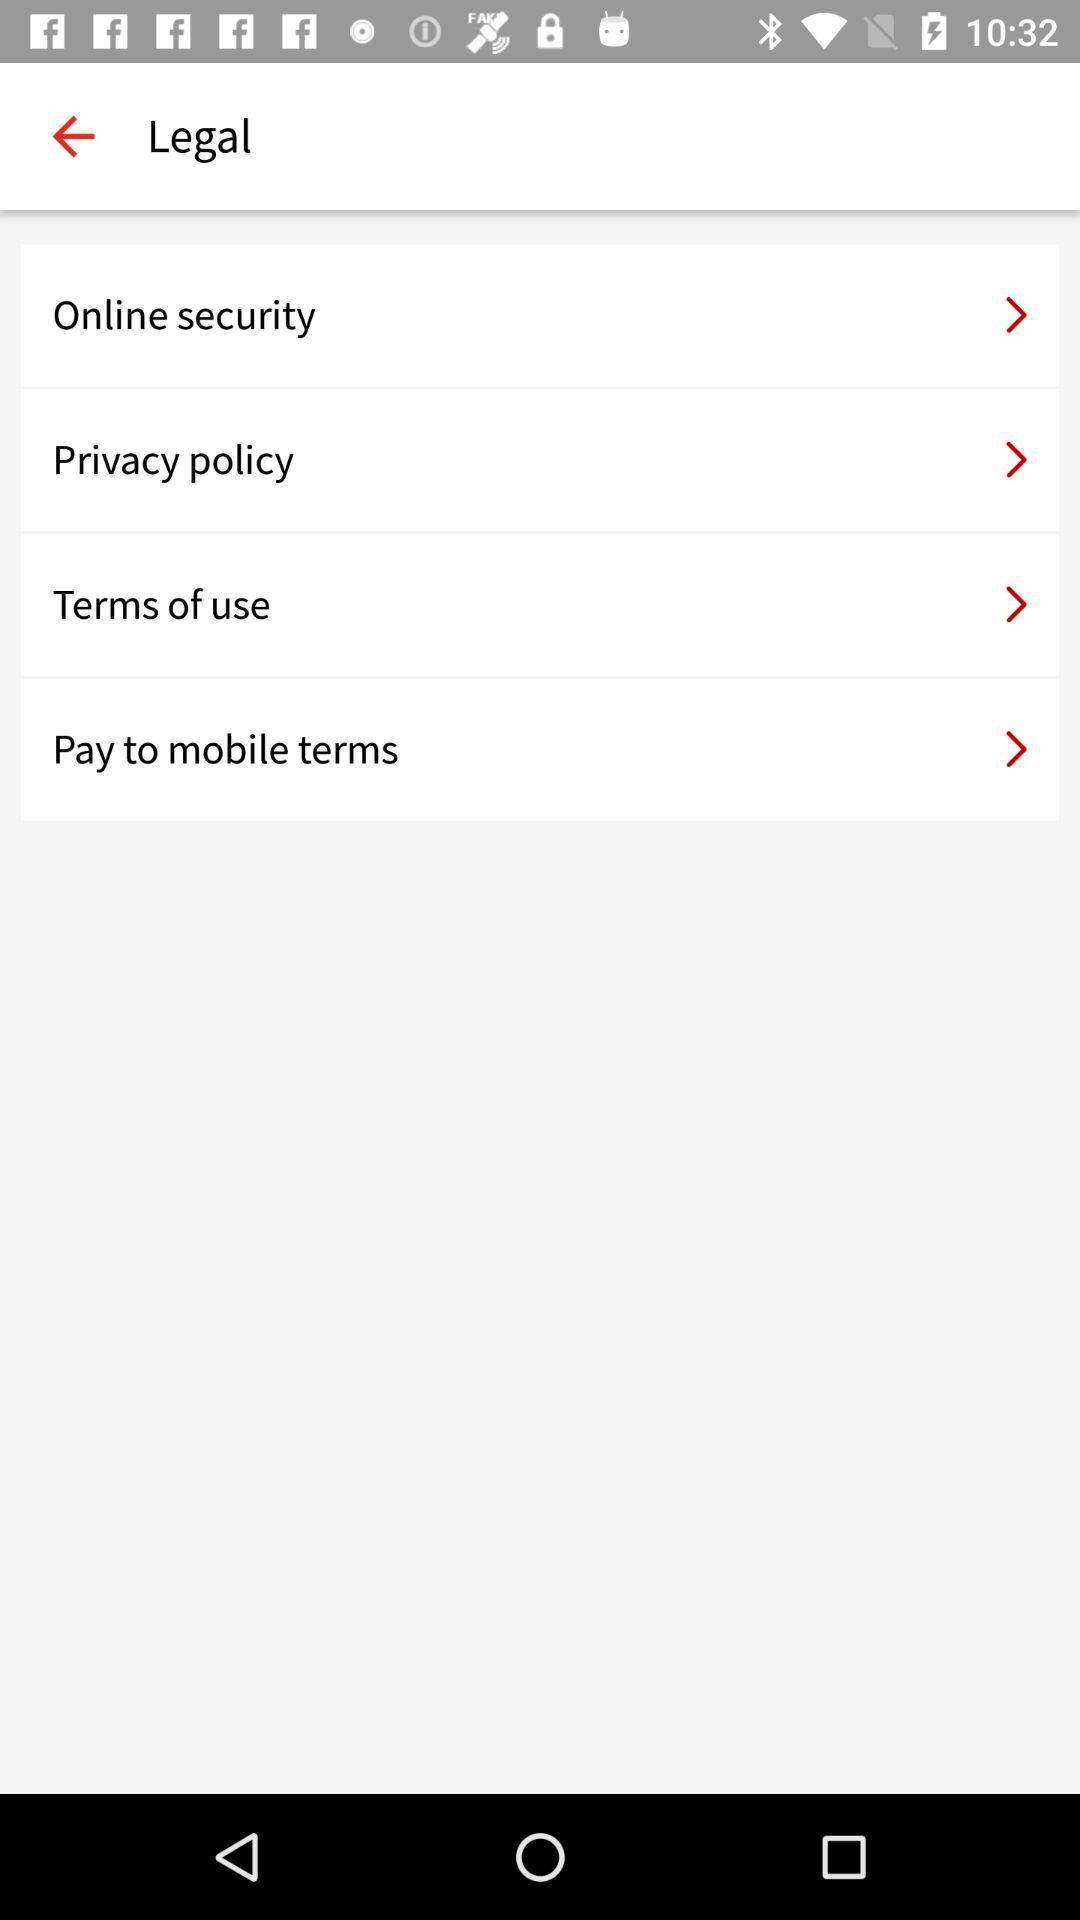How many terms of service do I need to agree to? Based on the image shown, you would need to agree to four separate terms of service: Online security, Privacy policy, Terms of use, and Pay to mobile terms. Each of these terms likely covers different aspects of service and data handling, essential for safeguarding your rights and privacy. 